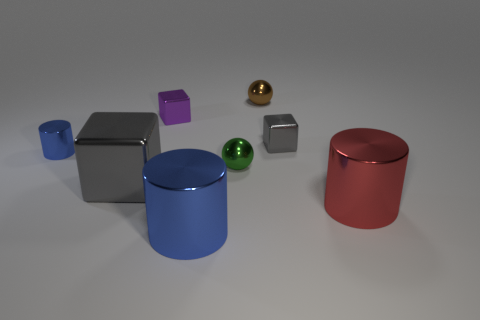Add 1 gray shiny things. How many objects exist? 9 Subtract all balls. How many objects are left? 6 Subtract 0 gray cylinders. How many objects are left? 8 Subtract all metallic balls. Subtract all big gray objects. How many objects are left? 5 Add 2 small blue things. How many small blue things are left? 3 Add 1 shiny cylinders. How many shiny cylinders exist? 4 